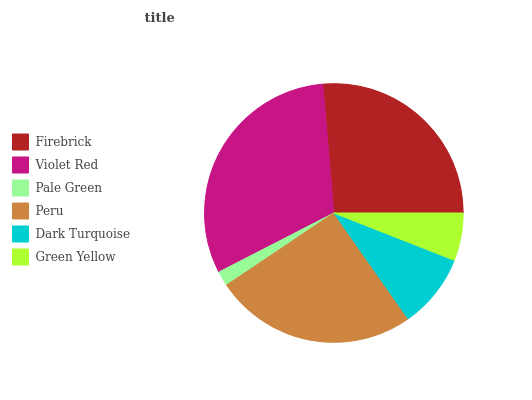Is Pale Green the minimum?
Answer yes or no. Yes. Is Violet Red the maximum?
Answer yes or no. Yes. Is Violet Red the minimum?
Answer yes or no. No. Is Pale Green the maximum?
Answer yes or no. No. Is Violet Red greater than Pale Green?
Answer yes or no. Yes. Is Pale Green less than Violet Red?
Answer yes or no. Yes. Is Pale Green greater than Violet Red?
Answer yes or no. No. Is Violet Red less than Pale Green?
Answer yes or no. No. Is Peru the high median?
Answer yes or no. Yes. Is Dark Turquoise the low median?
Answer yes or no. Yes. Is Firebrick the high median?
Answer yes or no. No. Is Peru the low median?
Answer yes or no. No. 